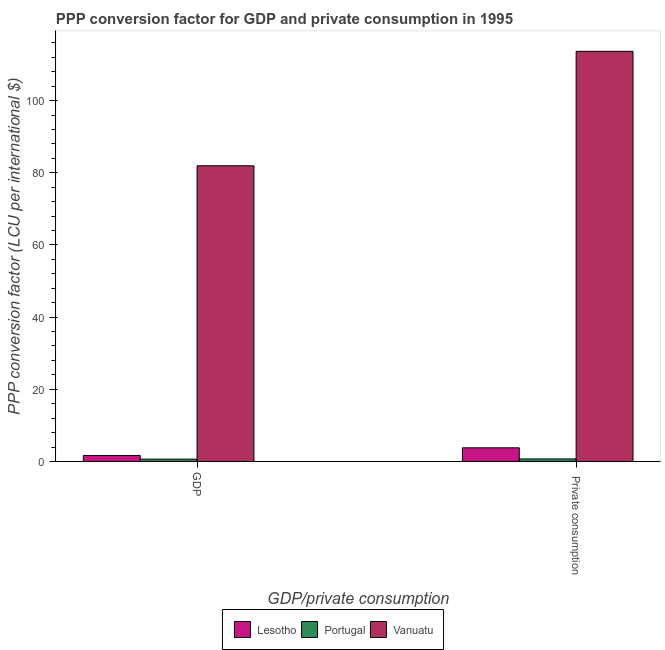How many different coloured bars are there?
Your answer should be very brief. 3. Are the number of bars on each tick of the X-axis equal?
Provide a succinct answer. Yes. How many bars are there on the 2nd tick from the left?
Make the answer very short. 3. How many bars are there on the 2nd tick from the right?
Your answer should be compact. 3. What is the label of the 2nd group of bars from the left?
Your response must be concise.  Private consumption. What is the ppp conversion factor for private consumption in Portugal?
Give a very brief answer. 0.7. Across all countries, what is the maximum ppp conversion factor for private consumption?
Keep it short and to the point. 113.64. Across all countries, what is the minimum ppp conversion factor for private consumption?
Make the answer very short. 0.7. In which country was the ppp conversion factor for gdp maximum?
Your answer should be very brief. Vanuatu. In which country was the ppp conversion factor for private consumption minimum?
Offer a terse response. Portugal. What is the total ppp conversion factor for private consumption in the graph?
Offer a very short reply. 118.13. What is the difference between the ppp conversion factor for gdp in Lesotho and that in Portugal?
Provide a short and direct response. 1.01. What is the difference between the ppp conversion factor for gdp in Portugal and the ppp conversion factor for private consumption in Lesotho?
Ensure brevity in your answer.  -3.14. What is the average ppp conversion factor for private consumption per country?
Offer a very short reply. 39.38. What is the difference between the ppp conversion factor for gdp and ppp conversion factor for private consumption in Vanuatu?
Offer a terse response. -31.71. What is the ratio of the ppp conversion factor for gdp in Lesotho to that in Portugal?
Your answer should be compact. 2.56. Is the ppp conversion factor for private consumption in Vanuatu less than that in Portugal?
Ensure brevity in your answer.  No. In how many countries, is the ppp conversion factor for private consumption greater than the average ppp conversion factor for private consumption taken over all countries?
Provide a succinct answer. 1. What does the 3rd bar from the left in  Private consumption represents?
Give a very brief answer. Vanuatu. Are all the bars in the graph horizontal?
Ensure brevity in your answer.  No. How many countries are there in the graph?
Offer a very short reply. 3. Are the values on the major ticks of Y-axis written in scientific E-notation?
Your answer should be very brief. No. Does the graph contain any zero values?
Keep it short and to the point. No. Where does the legend appear in the graph?
Provide a short and direct response. Bottom center. What is the title of the graph?
Give a very brief answer. PPP conversion factor for GDP and private consumption in 1995. What is the label or title of the X-axis?
Provide a short and direct response. GDP/private consumption. What is the label or title of the Y-axis?
Ensure brevity in your answer.  PPP conversion factor (LCU per international $). What is the PPP conversion factor (LCU per international $) in Lesotho in GDP?
Your answer should be compact. 1.66. What is the PPP conversion factor (LCU per international $) in Portugal in GDP?
Provide a short and direct response. 0.65. What is the PPP conversion factor (LCU per international $) of Vanuatu in GDP?
Keep it short and to the point. 81.93. What is the PPP conversion factor (LCU per international $) of Lesotho in  Private consumption?
Provide a succinct answer. 3.79. What is the PPP conversion factor (LCU per international $) of Portugal in  Private consumption?
Offer a very short reply. 0.7. What is the PPP conversion factor (LCU per international $) of Vanuatu in  Private consumption?
Make the answer very short. 113.64. Across all GDP/private consumption, what is the maximum PPP conversion factor (LCU per international $) in Lesotho?
Keep it short and to the point. 3.79. Across all GDP/private consumption, what is the maximum PPP conversion factor (LCU per international $) of Portugal?
Ensure brevity in your answer.  0.7. Across all GDP/private consumption, what is the maximum PPP conversion factor (LCU per international $) in Vanuatu?
Your answer should be very brief. 113.64. Across all GDP/private consumption, what is the minimum PPP conversion factor (LCU per international $) of Lesotho?
Keep it short and to the point. 1.66. Across all GDP/private consumption, what is the minimum PPP conversion factor (LCU per international $) of Portugal?
Provide a short and direct response. 0.65. Across all GDP/private consumption, what is the minimum PPP conversion factor (LCU per international $) in Vanuatu?
Your answer should be very brief. 81.93. What is the total PPP conversion factor (LCU per international $) in Lesotho in the graph?
Your response must be concise. 5.45. What is the total PPP conversion factor (LCU per international $) in Portugal in the graph?
Your response must be concise. 1.35. What is the total PPP conversion factor (LCU per international $) in Vanuatu in the graph?
Your response must be concise. 195.57. What is the difference between the PPP conversion factor (LCU per international $) of Lesotho in GDP and that in  Private consumption?
Offer a terse response. -2.12. What is the difference between the PPP conversion factor (LCU per international $) in Portugal in GDP and that in  Private consumption?
Your response must be concise. -0.05. What is the difference between the PPP conversion factor (LCU per international $) of Vanuatu in GDP and that in  Private consumption?
Provide a succinct answer. -31.71. What is the difference between the PPP conversion factor (LCU per international $) of Lesotho in GDP and the PPP conversion factor (LCU per international $) of Portugal in  Private consumption?
Provide a succinct answer. 0.96. What is the difference between the PPP conversion factor (LCU per international $) in Lesotho in GDP and the PPP conversion factor (LCU per international $) in Vanuatu in  Private consumption?
Provide a short and direct response. -111.98. What is the difference between the PPP conversion factor (LCU per international $) in Portugal in GDP and the PPP conversion factor (LCU per international $) in Vanuatu in  Private consumption?
Your answer should be compact. -112.99. What is the average PPP conversion factor (LCU per international $) of Lesotho per GDP/private consumption?
Your answer should be very brief. 2.72. What is the average PPP conversion factor (LCU per international $) of Portugal per GDP/private consumption?
Your answer should be compact. 0.67. What is the average PPP conversion factor (LCU per international $) in Vanuatu per GDP/private consumption?
Ensure brevity in your answer.  97.78. What is the difference between the PPP conversion factor (LCU per international $) in Lesotho and PPP conversion factor (LCU per international $) in Portugal in GDP?
Your answer should be compact. 1.01. What is the difference between the PPP conversion factor (LCU per international $) in Lesotho and PPP conversion factor (LCU per international $) in Vanuatu in GDP?
Make the answer very short. -80.27. What is the difference between the PPP conversion factor (LCU per international $) of Portugal and PPP conversion factor (LCU per international $) of Vanuatu in GDP?
Offer a very short reply. -81.28. What is the difference between the PPP conversion factor (LCU per international $) of Lesotho and PPP conversion factor (LCU per international $) of Portugal in  Private consumption?
Make the answer very short. 3.09. What is the difference between the PPP conversion factor (LCU per international $) in Lesotho and PPP conversion factor (LCU per international $) in Vanuatu in  Private consumption?
Keep it short and to the point. -109.86. What is the difference between the PPP conversion factor (LCU per international $) in Portugal and PPP conversion factor (LCU per international $) in Vanuatu in  Private consumption?
Make the answer very short. -112.94. What is the ratio of the PPP conversion factor (LCU per international $) in Lesotho in GDP to that in  Private consumption?
Your answer should be compact. 0.44. What is the ratio of the PPP conversion factor (LCU per international $) of Portugal in GDP to that in  Private consumption?
Offer a terse response. 0.93. What is the ratio of the PPP conversion factor (LCU per international $) of Vanuatu in GDP to that in  Private consumption?
Give a very brief answer. 0.72. What is the difference between the highest and the second highest PPP conversion factor (LCU per international $) of Lesotho?
Ensure brevity in your answer.  2.12. What is the difference between the highest and the second highest PPP conversion factor (LCU per international $) in Portugal?
Your answer should be very brief. 0.05. What is the difference between the highest and the second highest PPP conversion factor (LCU per international $) in Vanuatu?
Provide a succinct answer. 31.71. What is the difference between the highest and the lowest PPP conversion factor (LCU per international $) in Lesotho?
Ensure brevity in your answer.  2.12. What is the difference between the highest and the lowest PPP conversion factor (LCU per international $) in Portugal?
Your response must be concise. 0.05. What is the difference between the highest and the lowest PPP conversion factor (LCU per international $) of Vanuatu?
Provide a succinct answer. 31.71. 